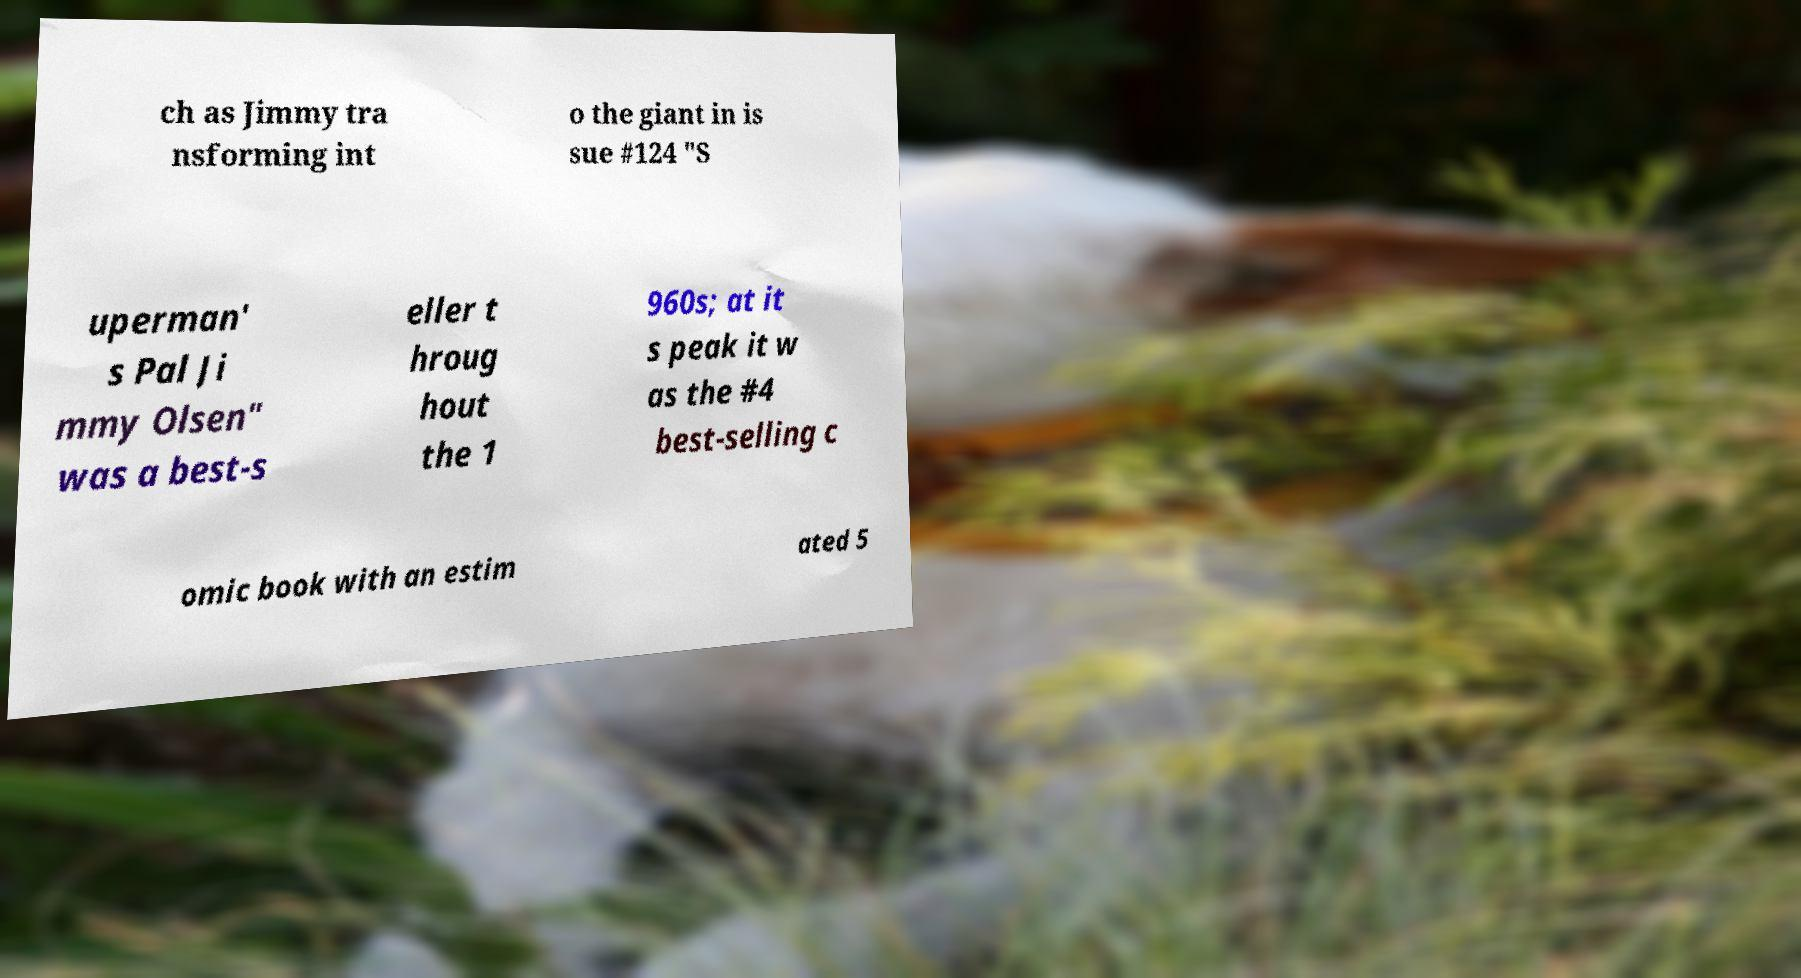I need the written content from this picture converted into text. Can you do that? ch as Jimmy tra nsforming int o the giant in is sue #124 "S uperman' s Pal Ji mmy Olsen" was a best-s eller t hroug hout the 1 960s; at it s peak it w as the #4 best-selling c omic book with an estim ated 5 